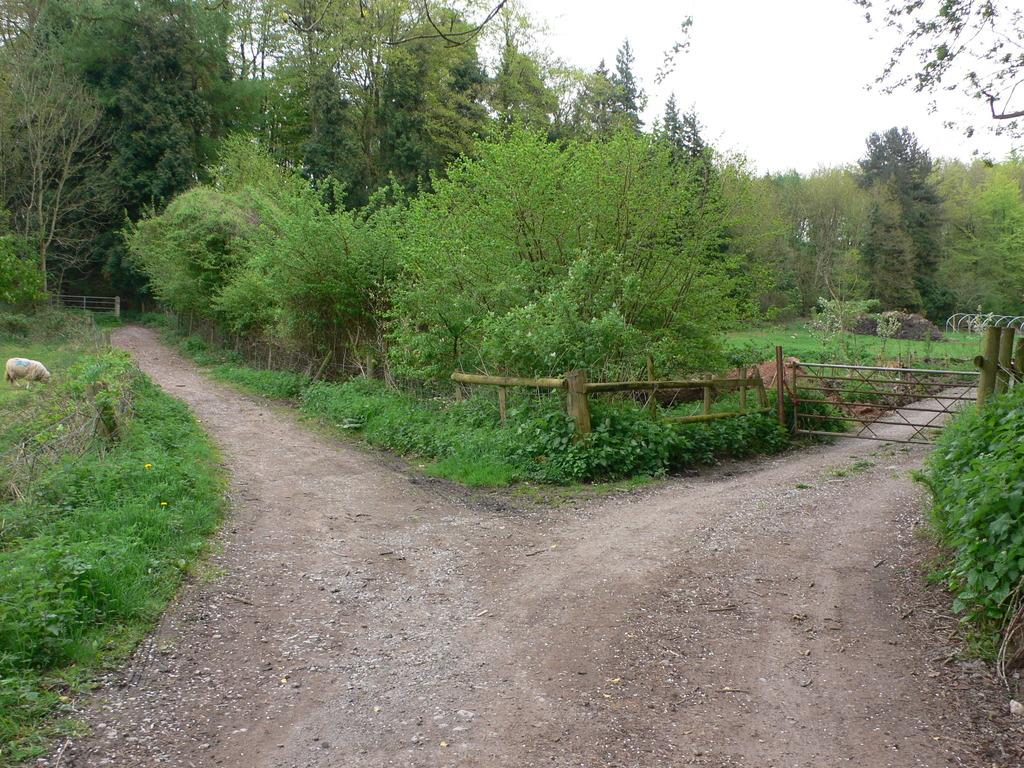What can be seen on the right side of the image? There is a boundary on the right side of the image. What type of environment is depicted in the image? There is greenery around the area of the image. How many clams can be seen in the image? There are no clams present in the image. What time of day is depicted in the image, based on the hour? The provided facts do not mention the time of day or any specific hour, so it cannot be determined from the image. 